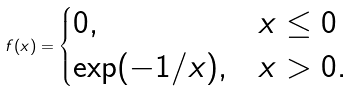<formula> <loc_0><loc_0><loc_500><loc_500>f ( x ) = \begin{cases} 0 , & x \leq 0 \\ \exp ( - 1 / x ) , & x > 0 . \end{cases}</formula> 